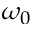<formula> <loc_0><loc_0><loc_500><loc_500>\omega _ { 0 }</formula> 